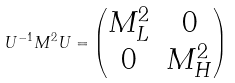Convert formula to latex. <formula><loc_0><loc_0><loc_500><loc_500>U ^ { - 1 } M ^ { 2 } U = \begin{pmatrix} M _ { L } ^ { 2 } & 0 \\ 0 & M _ { H } ^ { 2 } \end{pmatrix}</formula> 